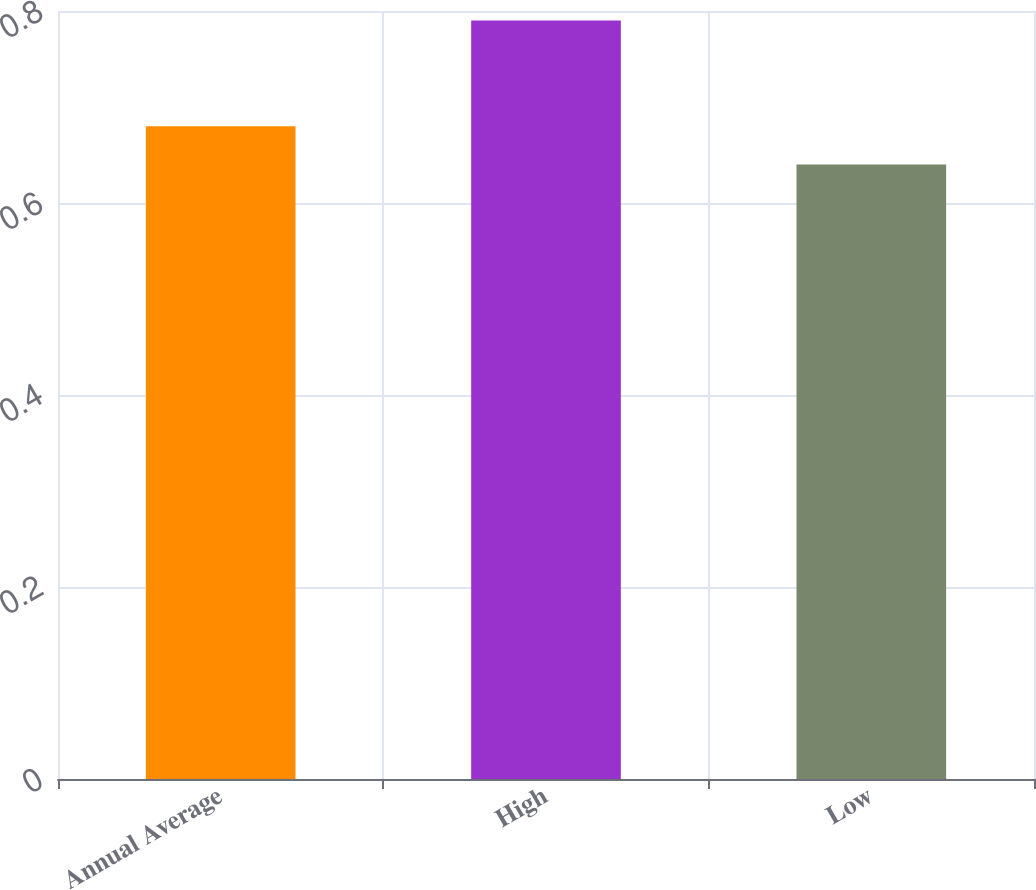<chart> <loc_0><loc_0><loc_500><loc_500><bar_chart><fcel>Annual Average<fcel>High<fcel>Low<nl><fcel>0.68<fcel>0.79<fcel>0.64<nl></chart> 